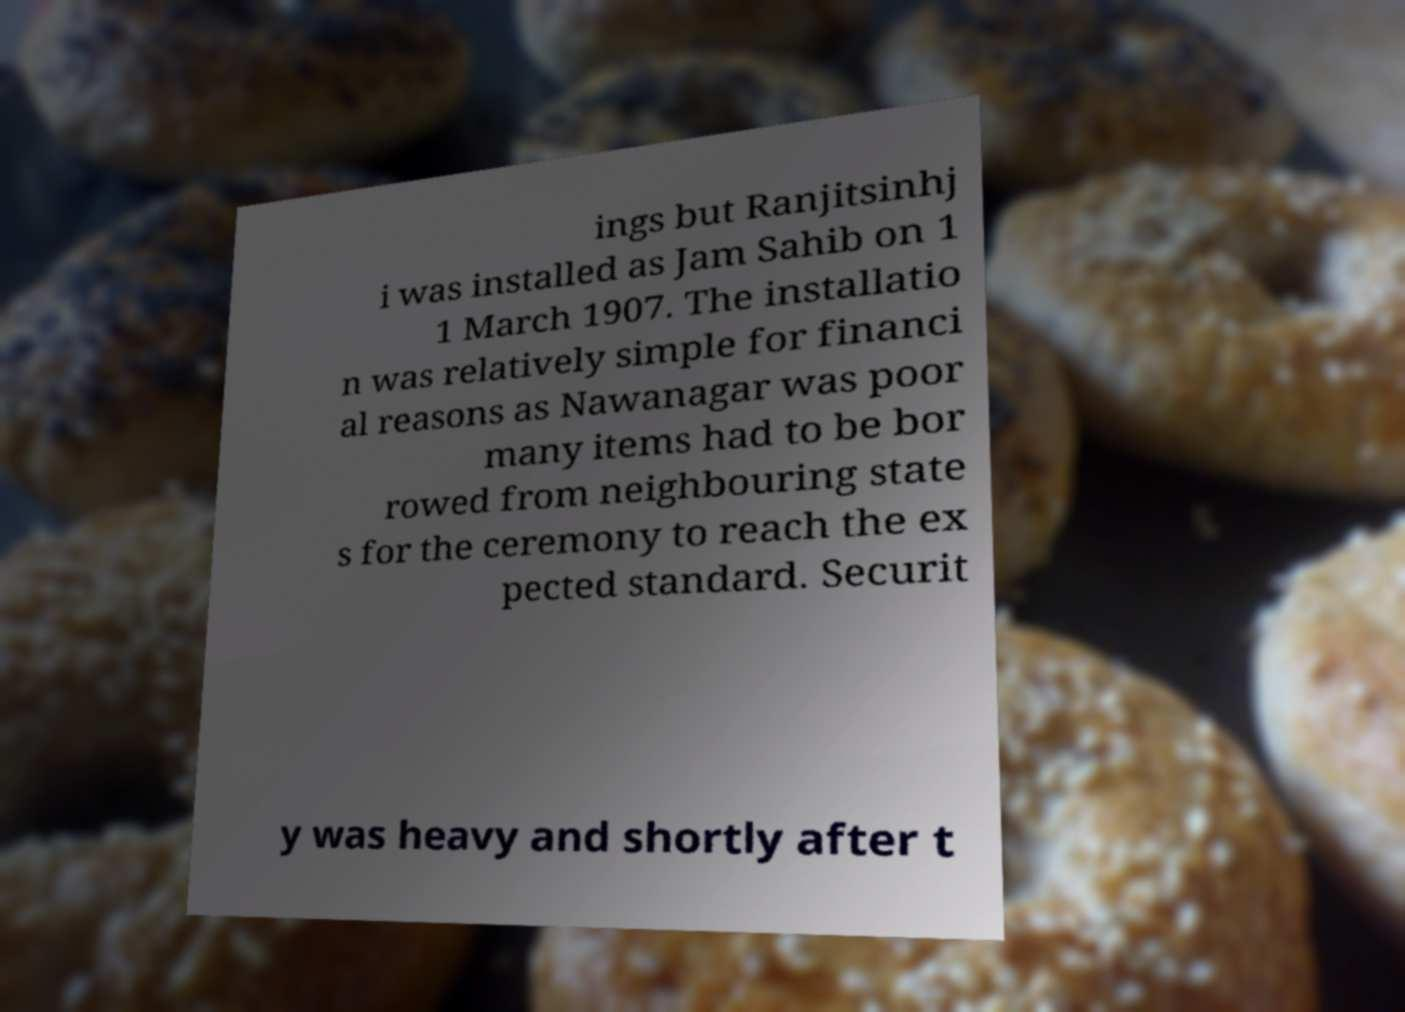Can you read and provide the text displayed in the image?This photo seems to have some interesting text. Can you extract and type it out for me? ings but Ranjitsinhj i was installed as Jam Sahib on 1 1 March 1907. The installatio n was relatively simple for financi al reasons as Nawanagar was poor many items had to be bor rowed from neighbouring state s for the ceremony to reach the ex pected standard. Securit y was heavy and shortly after t 